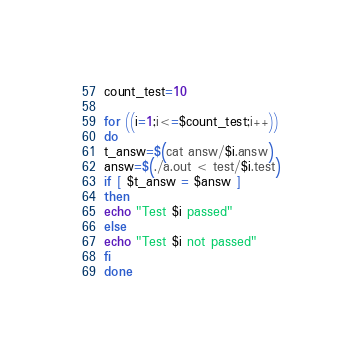Convert code to text. <code><loc_0><loc_0><loc_500><loc_500><_Bash_>count_test=10

for ((i=1;i<=$count_test;i++))
do
t_answ=$(cat answ/$i.answ)
answ=$(./a.out < test/$i.test)
if [ $t_answ = $answ ]
then
echo "Test $i passed"
else
echo "Test $i not passed"
fi
done
</code> 